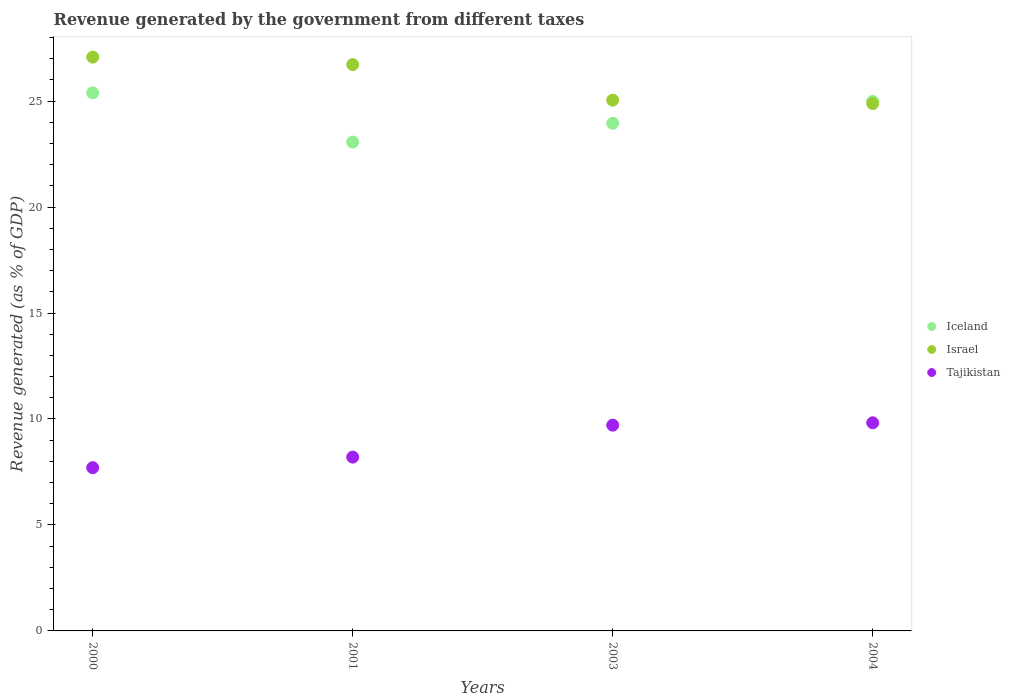How many different coloured dotlines are there?
Your answer should be very brief. 3. What is the revenue generated by the government in Iceland in 2001?
Make the answer very short. 23.07. Across all years, what is the maximum revenue generated by the government in Israel?
Provide a succinct answer. 27.08. Across all years, what is the minimum revenue generated by the government in Israel?
Offer a very short reply. 24.89. What is the total revenue generated by the government in Tajikistan in the graph?
Keep it short and to the point. 35.44. What is the difference between the revenue generated by the government in Israel in 2003 and that in 2004?
Keep it short and to the point. 0.16. What is the difference between the revenue generated by the government in Israel in 2004 and the revenue generated by the government in Tajikistan in 2003?
Give a very brief answer. 15.18. What is the average revenue generated by the government in Tajikistan per year?
Give a very brief answer. 8.86. In the year 2004, what is the difference between the revenue generated by the government in Tajikistan and revenue generated by the government in Iceland?
Keep it short and to the point. -15.16. What is the ratio of the revenue generated by the government in Iceland in 2000 to that in 2003?
Your response must be concise. 1.06. Is the revenue generated by the government in Israel in 2000 less than that in 2001?
Provide a short and direct response. No. Is the difference between the revenue generated by the government in Tajikistan in 2000 and 2004 greater than the difference between the revenue generated by the government in Iceland in 2000 and 2004?
Offer a terse response. No. What is the difference between the highest and the second highest revenue generated by the government in Iceland?
Your response must be concise. 0.4. What is the difference between the highest and the lowest revenue generated by the government in Tajikistan?
Ensure brevity in your answer.  2.12. In how many years, is the revenue generated by the government in Israel greater than the average revenue generated by the government in Israel taken over all years?
Offer a very short reply. 2. Does the revenue generated by the government in Israel monotonically increase over the years?
Provide a succinct answer. No. How many years are there in the graph?
Keep it short and to the point. 4. Are the values on the major ticks of Y-axis written in scientific E-notation?
Offer a terse response. No. How are the legend labels stacked?
Provide a short and direct response. Vertical. What is the title of the graph?
Ensure brevity in your answer.  Revenue generated by the government from different taxes. Does "Bulgaria" appear as one of the legend labels in the graph?
Offer a terse response. No. What is the label or title of the Y-axis?
Make the answer very short. Revenue generated (as % of GDP). What is the Revenue generated (as % of GDP) of Iceland in 2000?
Offer a terse response. 25.39. What is the Revenue generated (as % of GDP) in Israel in 2000?
Make the answer very short. 27.08. What is the Revenue generated (as % of GDP) in Tajikistan in 2000?
Keep it short and to the point. 7.7. What is the Revenue generated (as % of GDP) of Iceland in 2001?
Ensure brevity in your answer.  23.07. What is the Revenue generated (as % of GDP) of Israel in 2001?
Your response must be concise. 26.72. What is the Revenue generated (as % of GDP) in Tajikistan in 2001?
Your answer should be compact. 8.2. What is the Revenue generated (as % of GDP) of Iceland in 2003?
Your response must be concise. 23.95. What is the Revenue generated (as % of GDP) of Israel in 2003?
Your response must be concise. 25.05. What is the Revenue generated (as % of GDP) of Tajikistan in 2003?
Keep it short and to the point. 9.71. What is the Revenue generated (as % of GDP) in Iceland in 2004?
Your response must be concise. 24.98. What is the Revenue generated (as % of GDP) in Israel in 2004?
Keep it short and to the point. 24.89. What is the Revenue generated (as % of GDP) of Tajikistan in 2004?
Offer a terse response. 9.82. Across all years, what is the maximum Revenue generated (as % of GDP) in Iceland?
Ensure brevity in your answer.  25.39. Across all years, what is the maximum Revenue generated (as % of GDP) in Israel?
Make the answer very short. 27.08. Across all years, what is the maximum Revenue generated (as % of GDP) of Tajikistan?
Your answer should be compact. 9.82. Across all years, what is the minimum Revenue generated (as % of GDP) of Iceland?
Give a very brief answer. 23.07. Across all years, what is the minimum Revenue generated (as % of GDP) in Israel?
Your answer should be compact. 24.89. Across all years, what is the minimum Revenue generated (as % of GDP) of Tajikistan?
Your answer should be compact. 7.7. What is the total Revenue generated (as % of GDP) of Iceland in the graph?
Make the answer very short. 97.4. What is the total Revenue generated (as % of GDP) of Israel in the graph?
Provide a succinct answer. 103.73. What is the total Revenue generated (as % of GDP) in Tajikistan in the graph?
Offer a very short reply. 35.44. What is the difference between the Revenue generated (as % of GDP) in Iceland in 2000 and that in 2001?
Make the answer very short. 2.32. What is the difference between the Revenue generated (as % of GDP) of Israel in 2000 and that in 2001?
Your response must be concise. 0.35. What is the difference between the Revenue generated (as % of GDP) of Tajikistan in 2000 and that in 2001?
Provide a succinct answer. -0.5. What is the difference between the Revenue generated (as % of GDP) of Iceland in 2000 and that in 2003?
Provide a short and direct response. 1.44. What is the difference between the Revenue generated (as % of GDP) in Israel in 2000 and that in 2003?
Offer a very short reply. 2.03. What is the difference between the Revenue generated (as % of GDP) in Tajikistan in 2000 and that in 2003?
Give a very brief answer. -2.01. What is the difference between the Revenue generated (as % of GDP) of Iceland in 2000 and that in 2004?
Offer a terse response. 0.4. What is the difference between the Revenue generated (as % of GDP) in Israel in 2000 and that in 2004?
Your answer should be very brief. 2.19. What is the difference between the Revenue generated (as % of GDP) of Tajikistan in 2000 and that in 2004?
Make the answer very short. -2.12. What is the difference between the Revenue generated (as % of GDP) of Iceland in 2001 and that in 2003?
Your answer should be very brief. -0.89. What is the difference between the Revenue generated (as % of GDP) of Israel in 2001 and that in 2003?
Your answer should be compact. 1.68. What is the difference between the Revenue generated (as % of GDP) of Tajikistan in 2001 and that in 2003?
Give a very brief answer. -1.51. What is the difference between the Revenue generated (as % of GDP) of Iceland in 2001 and that in 2004?
Keep it short and to the point. -1.92. What is the difference between the Revenue generated (as % of GDP) of Israel in 2001 and that in 2004?
Make the answer very short. 1.84. What is the difference between the Revenue generated (as % of GDP) of Tajikistan in 2001 and that in 2004?
Provide a succinct answer. -1.62. What is the difference between the Revenue generated (as % of GDP) of Iceland in 2003 and that in 2004?
Give a very brief answer. -1.03. What is the difference between the Revenue generated (as % of GDP) of Israel in 2003 and that in 2004?
Make the answer very short. 0.16. What is the difference between the Revenue generated (as % of GDP) in Tajikistan in 2003 and that in 2004?
Give a very brief answer. -0.11. What is the difference between the Revenue generated (as % of GDP) in Iceland in 2000 and the Revenue generated (as % of GDP) in Israel in 2001?
Your answer should be very brief. -1.34. What is the difference between the Revenue generated (as % of GDP) of Iceland in 2000 and the Revenue generated (as % of GDP) of Tajikistan in 2001?
Ensure brevity in your answer.  17.19. What is the difference between the Revenue generated (as % of GDP) of Israel in 2000 and the Revenue generated (as % of GDP) of Tajikistan in 2001?
Make the answer very short. 18.87. What is the difference between the Revenue generated (as % of GDP) of Iceland in 2000 and the Revenue generated (as % of GDP) of Israel in 2003?
Ensure brevity in your answer.  0.34. What is the difference between the Revenue generated (as % of GDP) of Iceland in 2000 and the Revenue generated (as % of GDP) of Tajikistan in 2003?
Your response must be concise. 15.68. What is the difference between the Revenue generated (as % of GDP) in Israel in 2000 and the Revenue generated (as % of GDP) in Tajikistan in 2003?
Offer a very short reply. 17.37. What is the difference between the Revenue generated (as % of GDP) in Iceland in 2000 and the Revenue generated (as % of GDP) in Israel in 2004?
Offer a very short reply. 0.5. What is the difference between the Revenue generated (as % of GDP) in Iceland in 2000 and the Revenue generated (as % of GDP) in Tajikistan in 2004?
Offer a very short reply. 15.57. What is the difference between the Revenue generated (as % of GDP) in Israel in 2000 and the Revenue generated (as % of GDP) in Tajikistan in 2004?
Your answer should be compact. 17.26. What is the difference between the Revenue generated (as % of GDP) of Iceland in 2001 and the Revenue generated (as % of GDP) of Israel in 2003?
Offer a terse response. -1.98. What is the difference between the Revenue generated (as % of GDP) in Iceland in 2001 and the Revenue generated (as % of GDP) in Tajikistan in 2003?
Give a very brief answer. 13.36. What is the difference between the Revenue generated (as % of GDP) in Israel in 2001 and the Revenue generated (as % of GDP) in Tajikistan in 2003?
Provide a succinct answer. 17.02. What is the difference between the Revenue generated (as % of GDP) of Iceland in 2001 and the Revenue generated (as % of GDP) of Israel in 2004?
Keep it short and to the point. -1.82. What is the difference between the Revenue generated (as % of GDP) in Iceland in 2001 and the Revenue generated (as % of GDP) in Tajikistan in 2004?
Provide a succinct answer. 13.25. What is the difference between the Revenue generated (as % of GDP) in Israel in 2001 and the Revenue generated (as % of GDP) in Tajikistan in 2004?
Provide a short and direct response. 16.9. What is the difference between the Revenue generated (as % of GDP) in Iceland in 2003 and the Revenue generated (as % of GDP) in Israel in 2004?
Your answer should be compact. -0.93. What is the difference between the Revenue generated (as % of GDP) of Iceland in 2003 and the Revenue generated (as % of GDP) of Tajikistan in 2004?
Your answer should be compact. 14.13. What is the difference between the Revenue generated (as % of GDP) in Israel in 2003 and the Revenue generated (as % of GDP) in Tajikistan in 2004?
Your answer should be compact. 15.22. What is the average Revenue generated (as % of GDP) in Iceland per year?
Your response must be concise. 24.35. What is the average Revenue generated (as % of GDP) in Israel per year?
Make the answer very short. 25.93. What is the average Revenue generated (as % of GDP) of Tajikistan per year?
Ensure brevity in your answer.  8.86. In the year 2000, what is the difference between the Revenue generated (as % of GDP) of Iceland and Revenue generated (as % of GDP) of Israel?
Ensure brevity in your answer.  -1.69. In the year 2000, what is the difference between the Revenue generated (as % of GDP) in Iceland and Revenue generated (as % of GDP) in Tajikistan?
Keep it short and to the point. 17.69. In the year 2000, what is the difference between the Revenue generated (as % of GDP) in Israel and Revenue generated (as % of GDP) in Tajikistan?
Your answer should be compact. 19.37. In the year 2001, what is the difference between the Revenue generated (as % of GDP) in Iceland and Revenue generated (as % of GDP) in Israel?
Offer a terse response. -3.66. In the year 2001, what is the difference between the Revenue generated (as % of GDP) in Iceland and Revenue generated (as % of GDP) in Tajikistan?
Your answer should be very brief. 14.87. In the year 2001, what is the difference between the Revenue generated (as % of GDP) in Israel and Revenue generated (as % of GDP) in Tajikistan?
Give a very brief answer. 18.52. In the year 2003, what is the difference between the Revenue generated (as % of GDP) of Iceland and Revenue generated (as % of GDP) of Israel?
Make the answer very short. -1.09. In the year 2003, what is the difference between the Revenue generated (as % of GDP) in Iceland and Revenue generated (as % of GDP) in Tajikistan?
Your answer should be very brief. 14.24. In the year 2003, what is the difference between the Revenue generated (as % of GDP) of Israel and Revenue generated (as % of GDP) of Tajikistan?
Give a very brief answer. 15.34. In the year 2004, what is the difference between the Revenue generated (as % of GDP) in Iceland and Revenue generated (as % of GDP) in Israel?
Provide a succinct answer. 0.1. In the year 2004, what is the difference between the Revenue generated (as % of GDP) of Iceland and Revenue generated (as % of GDP) of Tajikistan?
Provide a succinct answer. 15.16. In the year 2004, what is the difference between the Revenue generated (as % of GDP) in Israel and Revenue generated (as % of GDP) in Tajikistan?
Offer a terse response. 15.06. What is the ratio of the Revenue generated (as % of GDP) in Iceland in 2000 to that in 2001?
Provide a succinct answer. 1.1. What is the ratio of the Revenue generated (as % of GDP) of Israel in 2000 to that in 2001?
Provide a succinct answer. 1.01. What is the ratio of the Revenue generated (as % of GDP) of Tajikistan in 2000 to that in 2001?
Offer a very short reply. 0.94. What is the ratio of the Revenue generated (as % of GDP) of Iceland in 2000 to that in 2003?
Your answer should be very brief. 1.06. What is the ratio of the Revenue generated (as % of GDP) in Israel in 2000 to that in 2003?
Your answer should be very brief. 1.08. What is the ratio of the Revenue generated (as % of GDP) of Tajikistan in 2000 to that in 2003?
Give a very brief answer. 0.79. What is the ratio of the Revenue generated (as % of GDP) in Iceland in 2000 to that in 2004?
Keep it short and to the point. 1.02. What is the ratio of the Revenue generated (as % of GDP) in Israel in 2000 to that in 2004?
Offer a terse response. 1.09. What is the ratio of the Revenue generated (as % of GDP) in Tajikistan in 2000 to that in 2004?
Ensure brevity in your answer.  0.78. What is the ratio of the Revenue generated (as % of GDP) of Iceland in 2001 to that in 2003?
Ensure brevity in your answer.  0.96. What is the ratio of the Revenue generated (as % of GDP) in Israel in 2001 to that in 2003?
Offer a terse response. 1.07. What is the ratio of the Revenue generated (as % of GDP) in Tajikistan in 2001 to that in 2003?
Your answer should be compact. 0.84. What is the ratio of the Revenue generated (as % of GDP) of Iceland in 2001 to that in 2004?
Your response must be concise. 0.92. What is the ratio of the Revenue generated (as % of GDP) of Israel in 2001 to that in 2004?
Offer a very short reply. 1.07. What is the ratio of the Revenue generated (as % of GDP) of Tajikistan in 2001 to that in 2004?
Make the answer very short. 0.84. What is the ratio of the Revenue generated (as % of GDP) in Iceland in 2003 to that in 2004?
Provide a succinct answer. 0.96. What is the ratio of the Revenue generated (as % of GDP) of Israel in 2003 to that in 2004?
Provide a short and direct response. 1.01. What is the ratio of the Revenue generated (as % of GDP) of Tajikistan in 2003 to that in 2004?
Keep it short and to the point. 0.99. What is the difference between the highest and the second highest Revenue generated (as % of GDP) of Iceland?
Your response must be concise. 0.4. What is the difference between the highest and the second highest Revenue generated (as % of GDP) of Israel?
Provide a short and direct response. 0.35. What is the difference between the highest and the second highest Revenue generated (as % of GDP) of Tajikistan?
Keep it short and to the point. 0.11. What is the difference between the highest and the lowest Revenue generated (as % of GDP) in Iceland?
Keep it short and to the point. 2.32. What is the difference between the highest and the lowest Revenue generated (as % of GDP) of Israel?
Provide a succinct answer. 2.19. What is the difference between the highest and the lowest Revenue generated (as % of GDP) of Tajikistan?
Make the answer very short. 2.12. 